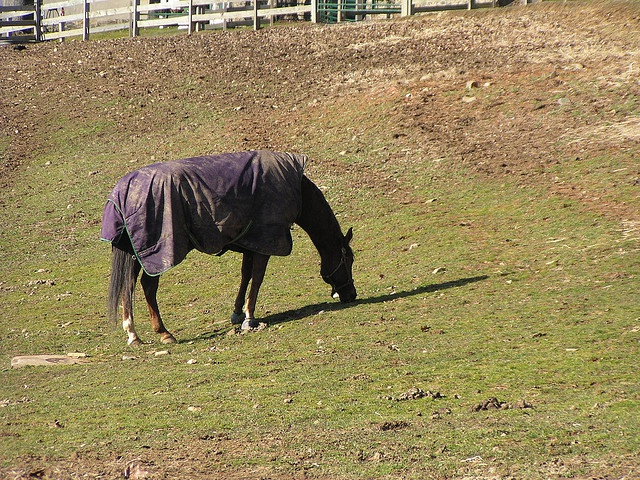Describe the objects in this image and their specific colors. I can see a horse in gray, black, and darkgray tones in this image. 